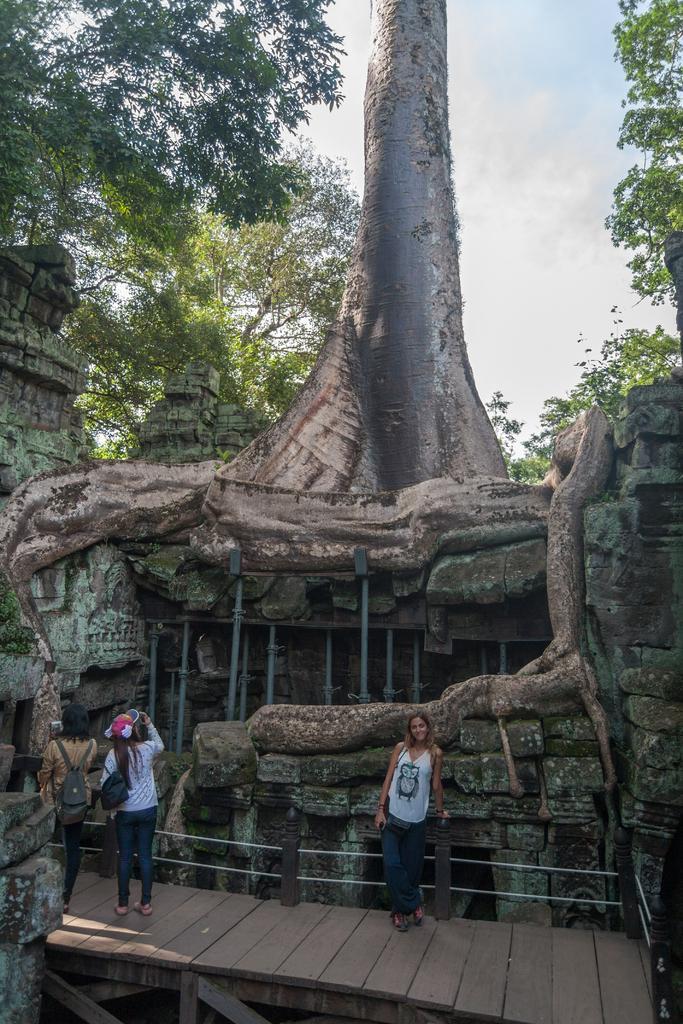How would you summarize this image in a sentence or two? In this image we can see three persons standing and wearing the bags, among them, two are holding the cameras, there are some trees, poles and wooden surface, also we can see the wall and in the background, we can see the sky with clouds. 